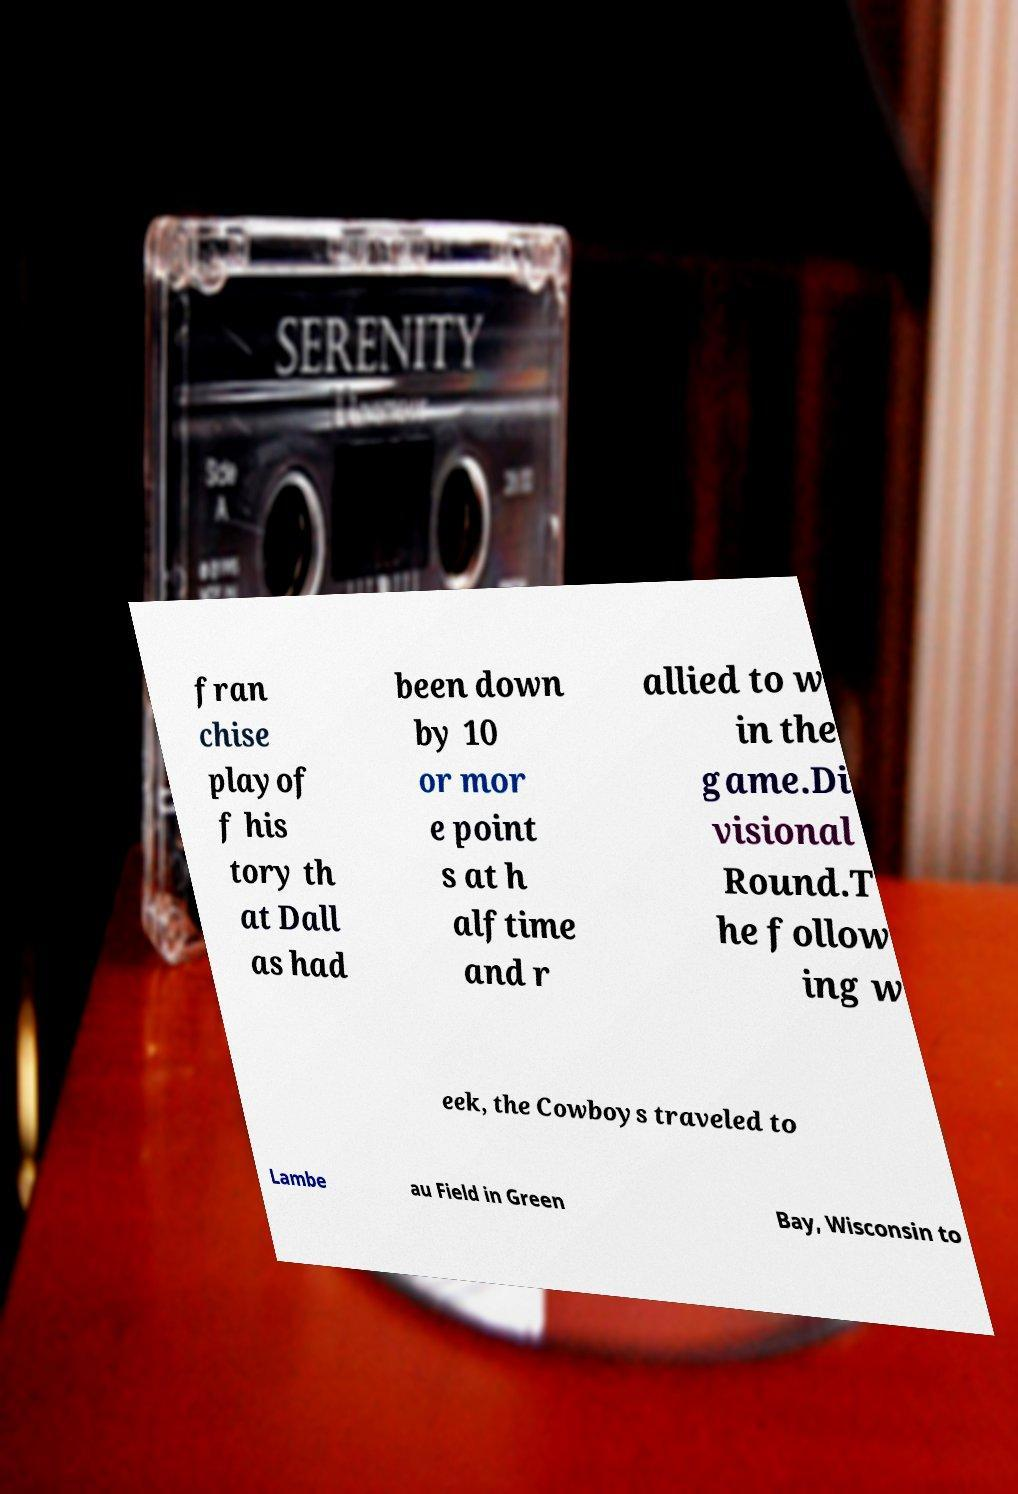For documentation purposes, I need the text within this image transcribed. Could you provide that? fran chise playof f his tory th at Dall as had been down by 10 or mor e point s at h alftime and r allied to w in the game.Di visional Round.T he follow ing w eek, the Cowboys traveled to Lambe au Field in Green Bay, Wisconsin to 